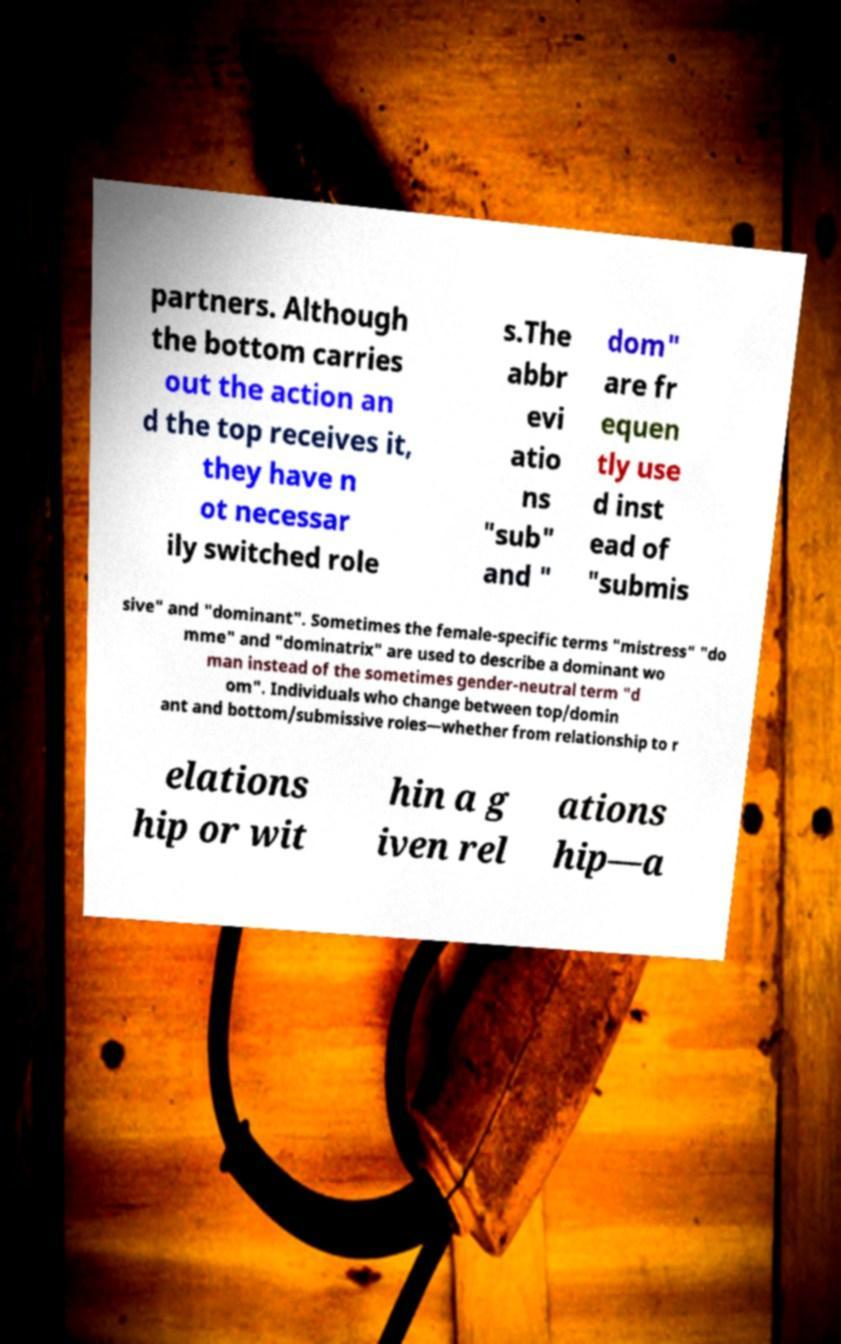I need the written content from this picture converted into text. Can you do that? partners. Although the bottom carries out the action an d the top receives it, they have n ot necessar ily switched role s.The abbr evi atio ns "sub" and " dom" are fr equen tly use d inst ead of "submis sive" and "dominant". Sometimes the female-specific terms "mistress" "do mme" and "dominatrix" are used to describe a dominant wo man instead of the sometimes gender-neutral term "d om". Individuals who change between top/domin ant and bottom/submissive roles—whether from relationship to r elations hip or wit hin a g iven rel ations hip—a 